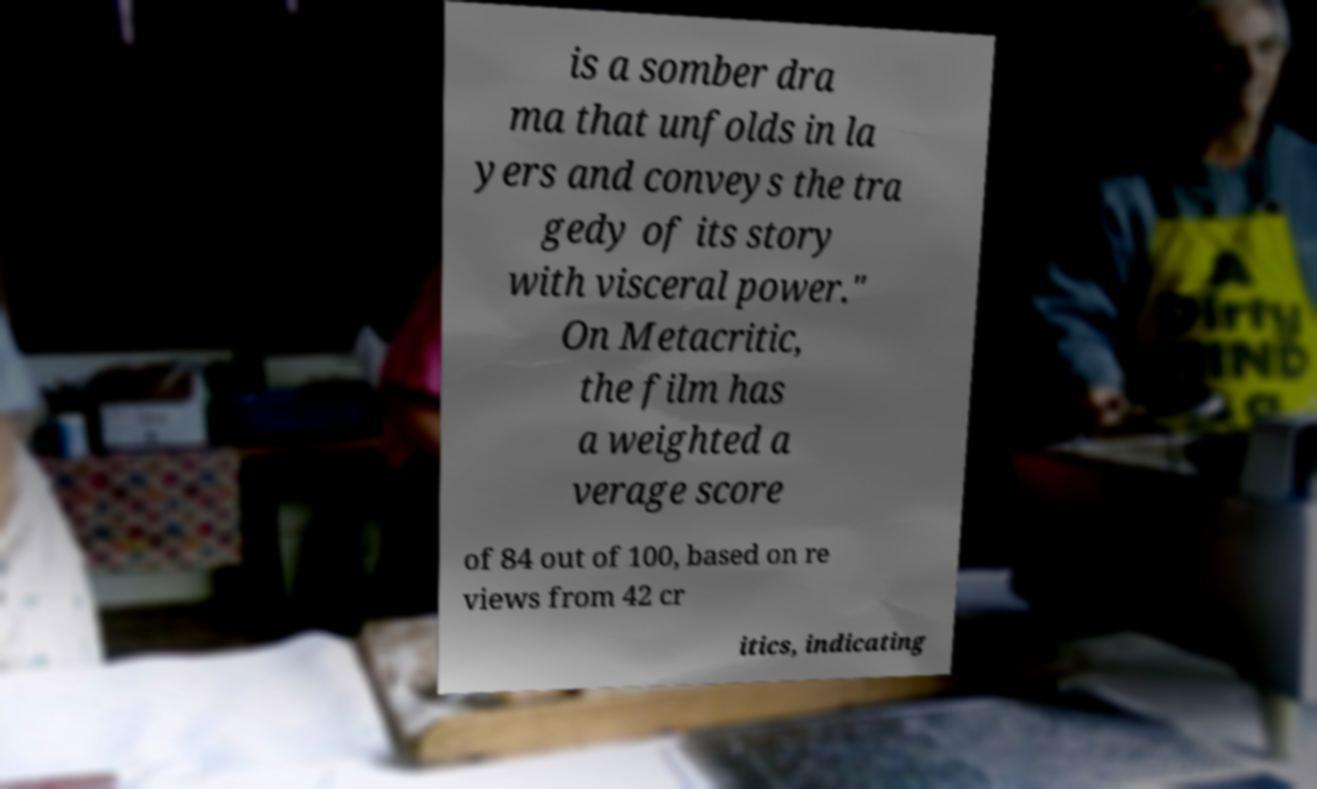Can you read and provide the text displayed in the image?This photo seems to have some interesting text. Can you extract and type it out for me? is a somber dra ma that unfolds in la yers and conveys the tra gedy of its story with visceral power." On Metacritic, the film has a weighted a verage score of 84 out of 100, based on re views from 42 cr itics, indicating 